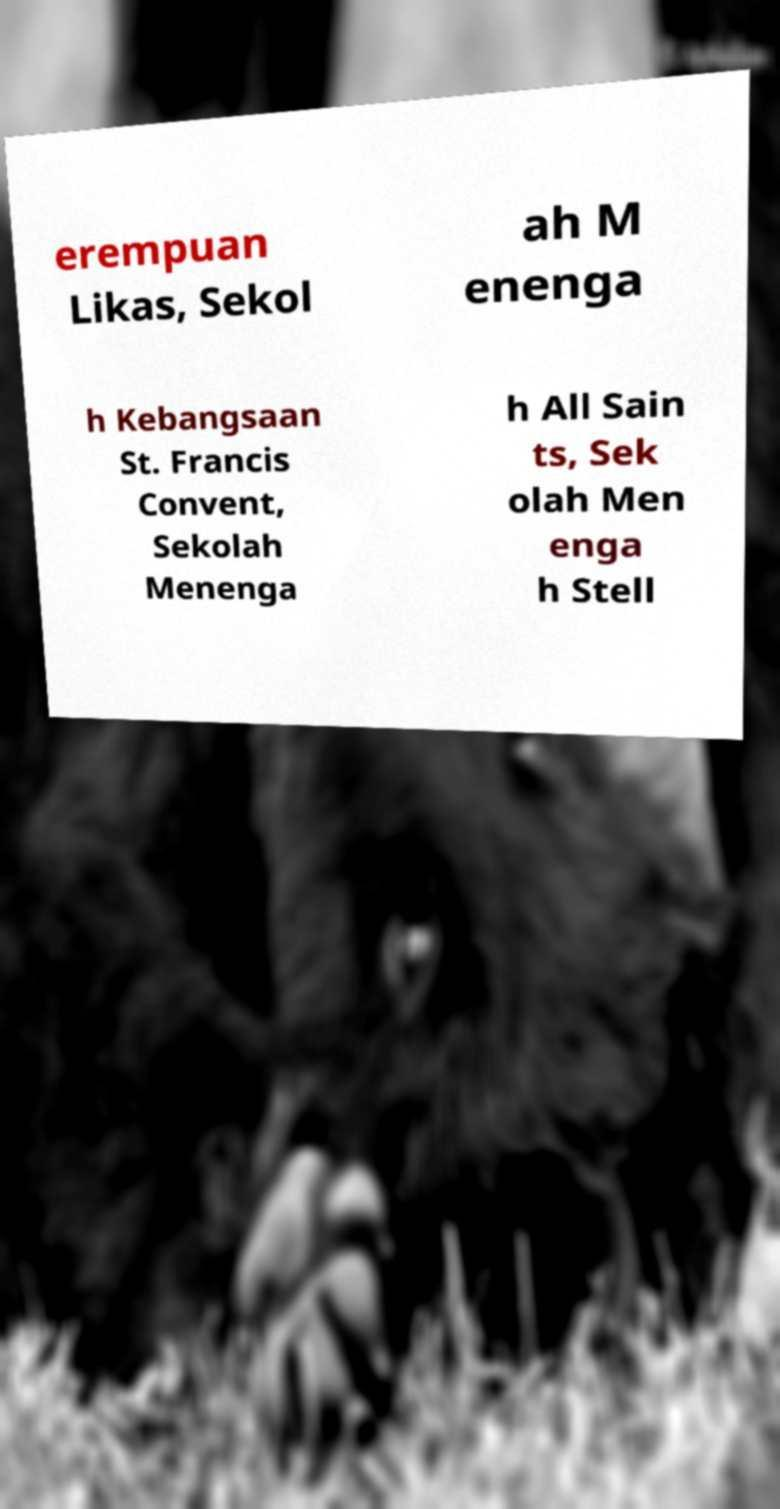For documentation purposes, I need the text within this image transcribed. Could you provide that? erempuan Likas, Sekol ah M enenga h Kebangsaan St. Francis Convent, Sekolah Menenga h All Sain ts, Sek olah Men enga h Stell 